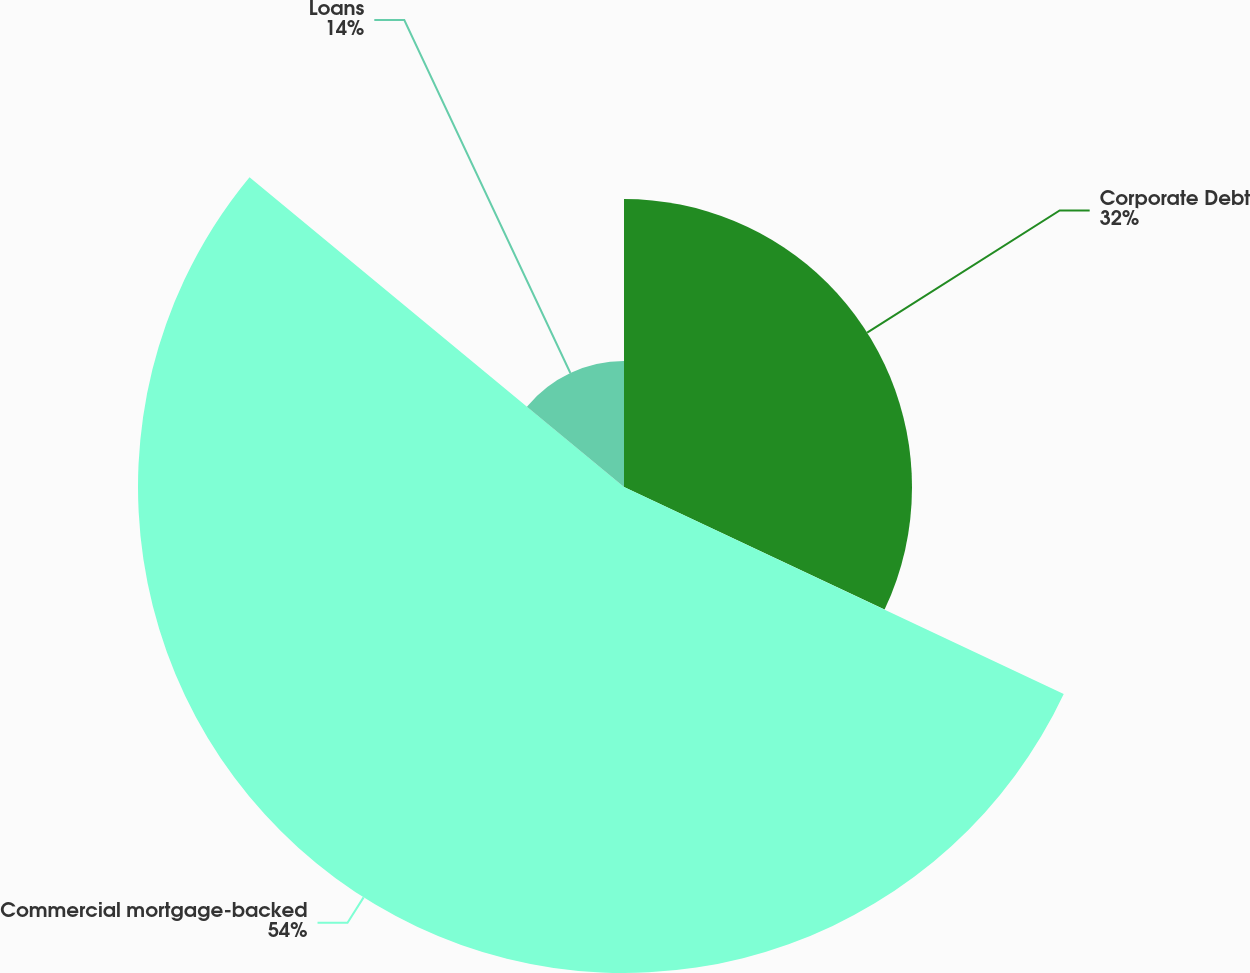Convert chart to OTSL. <chart><loc_0><loc_0><loc_500><loc_500><pie_chart><fcel>Corporate Debt<fcel>Commercial mortgage-backed<fcel>Loans<nl><fcel>32.0%<fcel>54.0%<fcel>14.0%<nl></chart> 